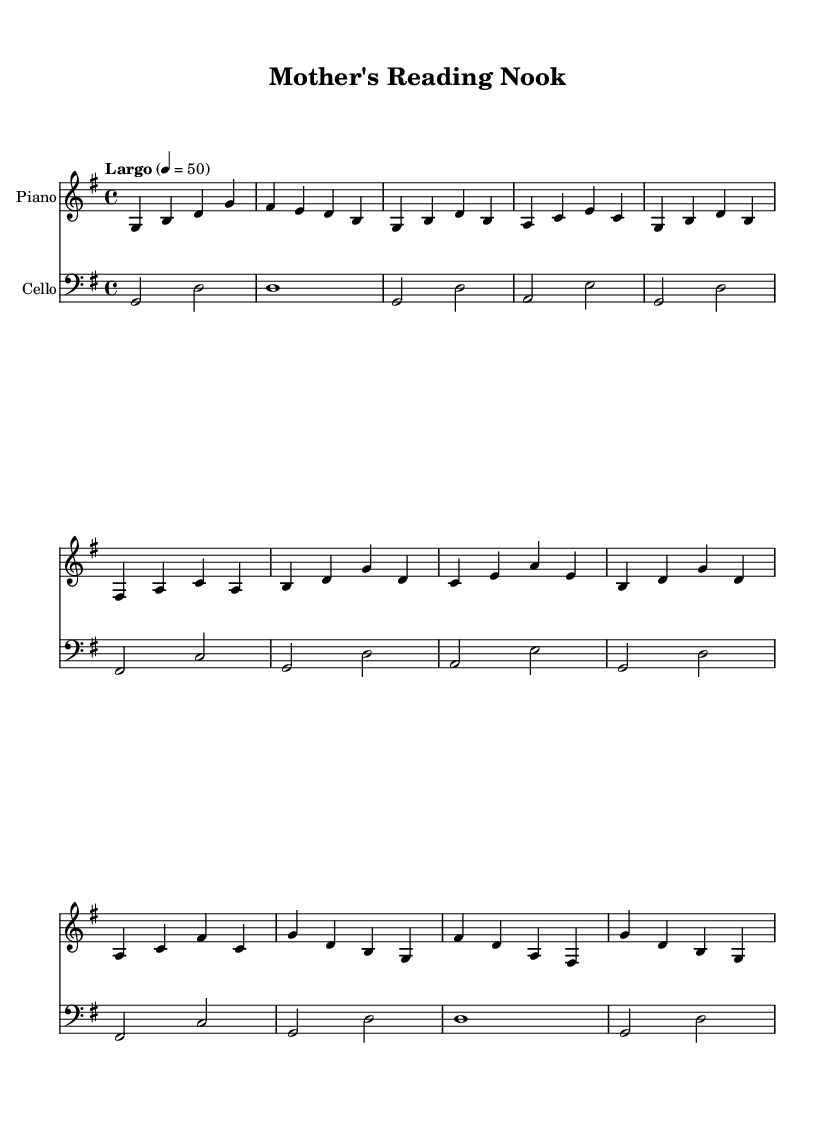What is the key signature of this music? The key signature is G major, which has one sharp (F#).
Answer: G major What is the time signature of this piece? The time signature indicated is 4/4, which means there are four beats in each measure.
Answer: 4/4 What is the tempo marking for this piece? The tempo marking is "Largo," which indicates a slow pace, specifically 50 beats per minute.
Answer: Largo How many measures are in the piano part? By counting the grouped measures in the piano part, there are a total of 11 measures.
Answer: 11 What instruments are present in this score? The score contains two instruments: Piano and Cello, as indicated by the staff headings.
Answer: Piano and Cello What is the last note in the cello part? The last note in the cello part is D, which is located at the end of the last measure of the staff.
Answer: D How does the mood of the music align with its title? The title "Mother's Reading Nook" suggests a serene and cozy atmosphere, which is conveyed through the gentle melodies and slow tempo, perfect for background reading.
Answer: Serene and cozy 